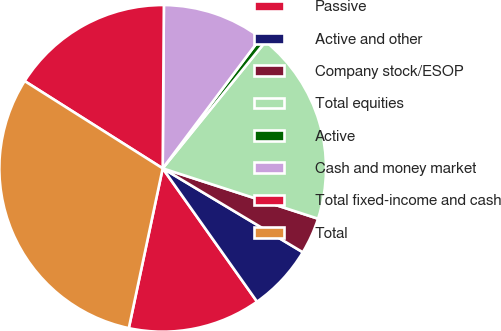<chart> <loc_0><loc_0><loc_500><loc_500><pie_chart><fcel>Passive<fcel>Active and other<fcel>Company stock/ESOP<fcel>Total equities<fcel>Active<fcel>Cash and money market<fcel>Total fixed-income and cash<fcel>Total<nl><fcel>13.13%<fcel>6.61%<fcel>3.6%<fcel>19.14%<fcel>0.6%<fcel>10.13%<fcel>16.14%<fcel>30.65%<nl></chart> 